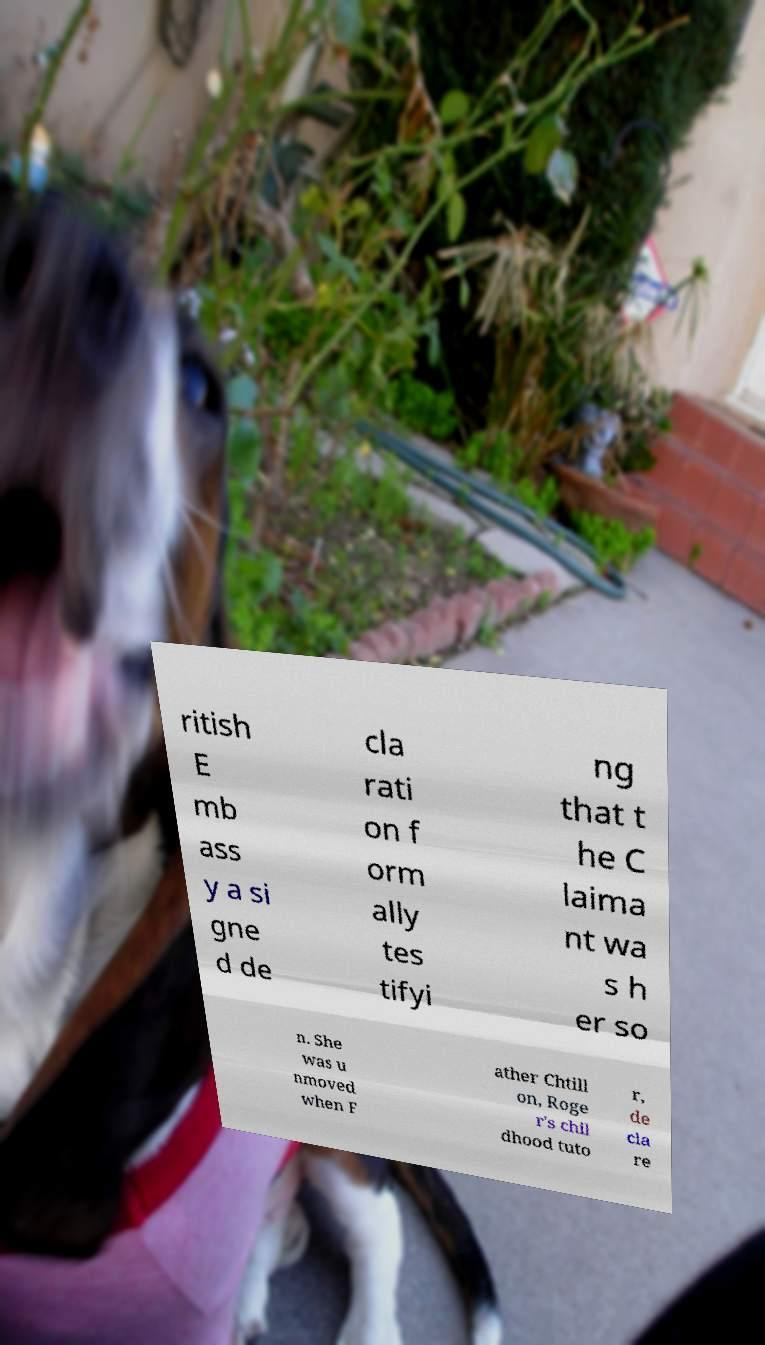Please read and relay the text visible in this image. What does it say? ritish E mb ass y a si gne d de cla rati on f orm ally tes tifyi ng that t he C laima nt wa s h er so n. She was u nmoved when F ather Chtill on, Roge r's chil dhood tuto r, de cla re 